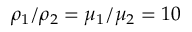Convert formula to latex. <formula><loc_0><loc_0><loc_500><loc_500>\rho _ { 1 } / \rho _ { 2 } = \mu _ { 1 } / \mu _ { 2 } = 1 0</formula> 